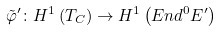Convert formula to latex. <formula><loc_0><loc_0><loc_500><loc_500>\tilde { \varphi } ^ { \prime } \colon H ^ { 1 } \left ( T _ { C } \right ) \rightarrow H ^ { 1 } \left ( E n d ^ { 0 } E ^ { \prime } \right )</formula> 